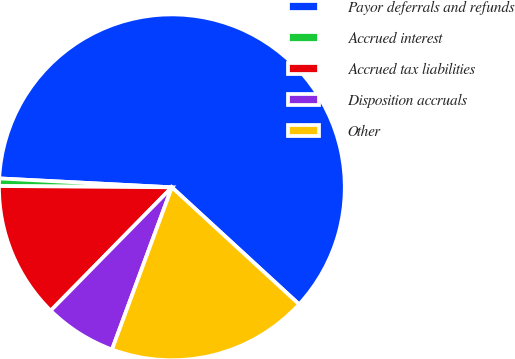Convert chart to OTSL. <chart><loc_0><loc_0><loc_500><loc_500><pie_chart><fcel>Payor deferrals and refunds<fcel>Accrued interest<fcel>Accrued tax liabilities<fcel>Disposition accruals<fcel>Other<nl><fcel>61.01%<fcel>0.7%<fcel>12.76%<fcel>6.73%<fcel>18.79%<nl></chart> 